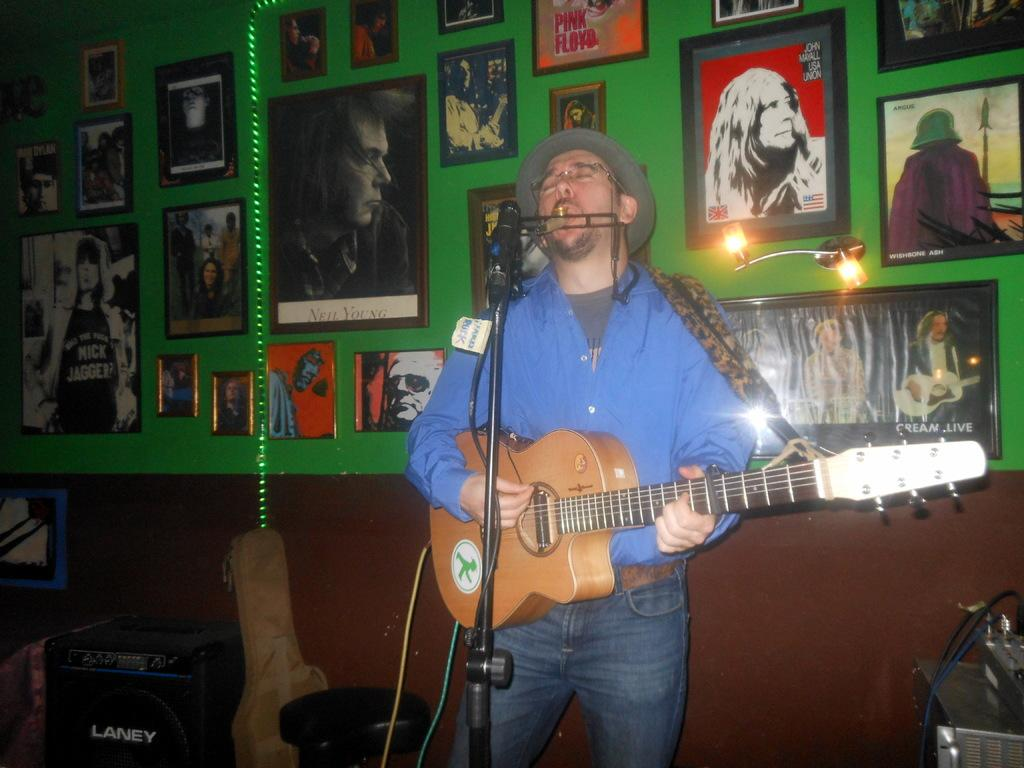What is the person in the image doing? The person is playing a guitar and singing. What object is the person using to amplify their voice? There is a microphone with a stand in the image. What can be seen on the wall in the background? There are frames and posters on the wall. What type of furniture is present in the image? There are chairs in the image. What is used for sound reinforcement in the image? There are speakers on the floor. How many boats are visible in the image? There are no boats present in the image. What type of boot is the person wearing in the image? The person's footwear is not visible in the image, so it cannot be determined if they are wearing a boot or any other type of shoe. 